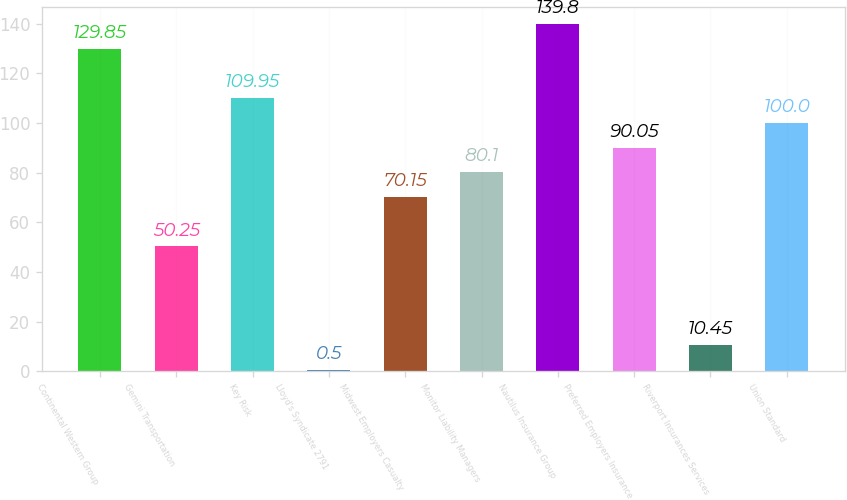Convert chart to OTSL. <chart><loc_0><loc_0><loc_500><loc_500><bar_chart><fcel>Continental Western Group<fcel>Gemini Transportation<fcel>Key Risk<fcel>Lloyd's Syndicate 2791<fcel>Midwest Employers Casualty<fcel>Monitor Liability Managers<fcel>Nautilus Insurance Group<fcel>Preferred Employers Insurance<fcel>Riverport Insurances Services<fcel>Union Standard<nl><fcel>129.85<fcel>50.25<fcel>109.95<fcel>0.5<fcel>70.15<fcel>80.1<fcel>139.8<fcel>90.05<fcel>10.45<fcel>100<nl></chart> 